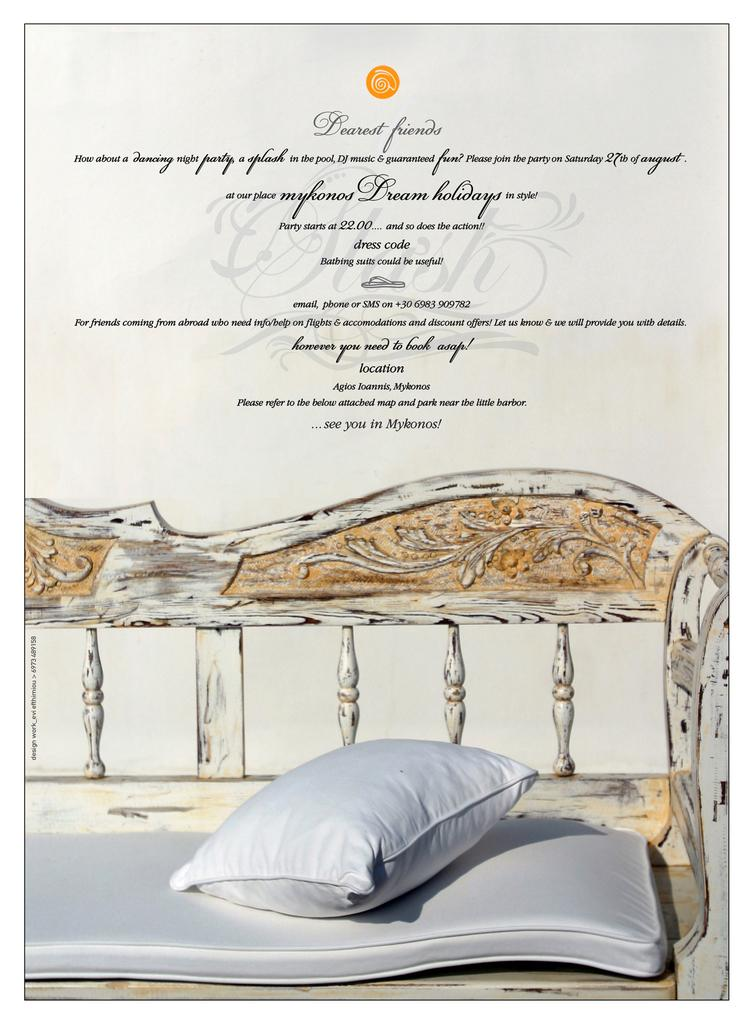What is present in the image that contains text? There is a poster in the image that contains text. What can be found at the bottom of the poster? There are images of a couch, a mattress, and a pillow at the bottom of the poster. What type of shoe is being advertised on the poster? There is no shoe being advertised on the poster; it features images of a couch, a mattress, and a pillow. How many baseballs are visible on the poster? There are no baseballs present on the poster. 